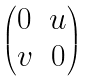<formula> <loc_0><loc_0><loc_500><loc_500>\begin{pmatrix} 0 & u \\ v & 0 \end{pmatrix}</formula> 